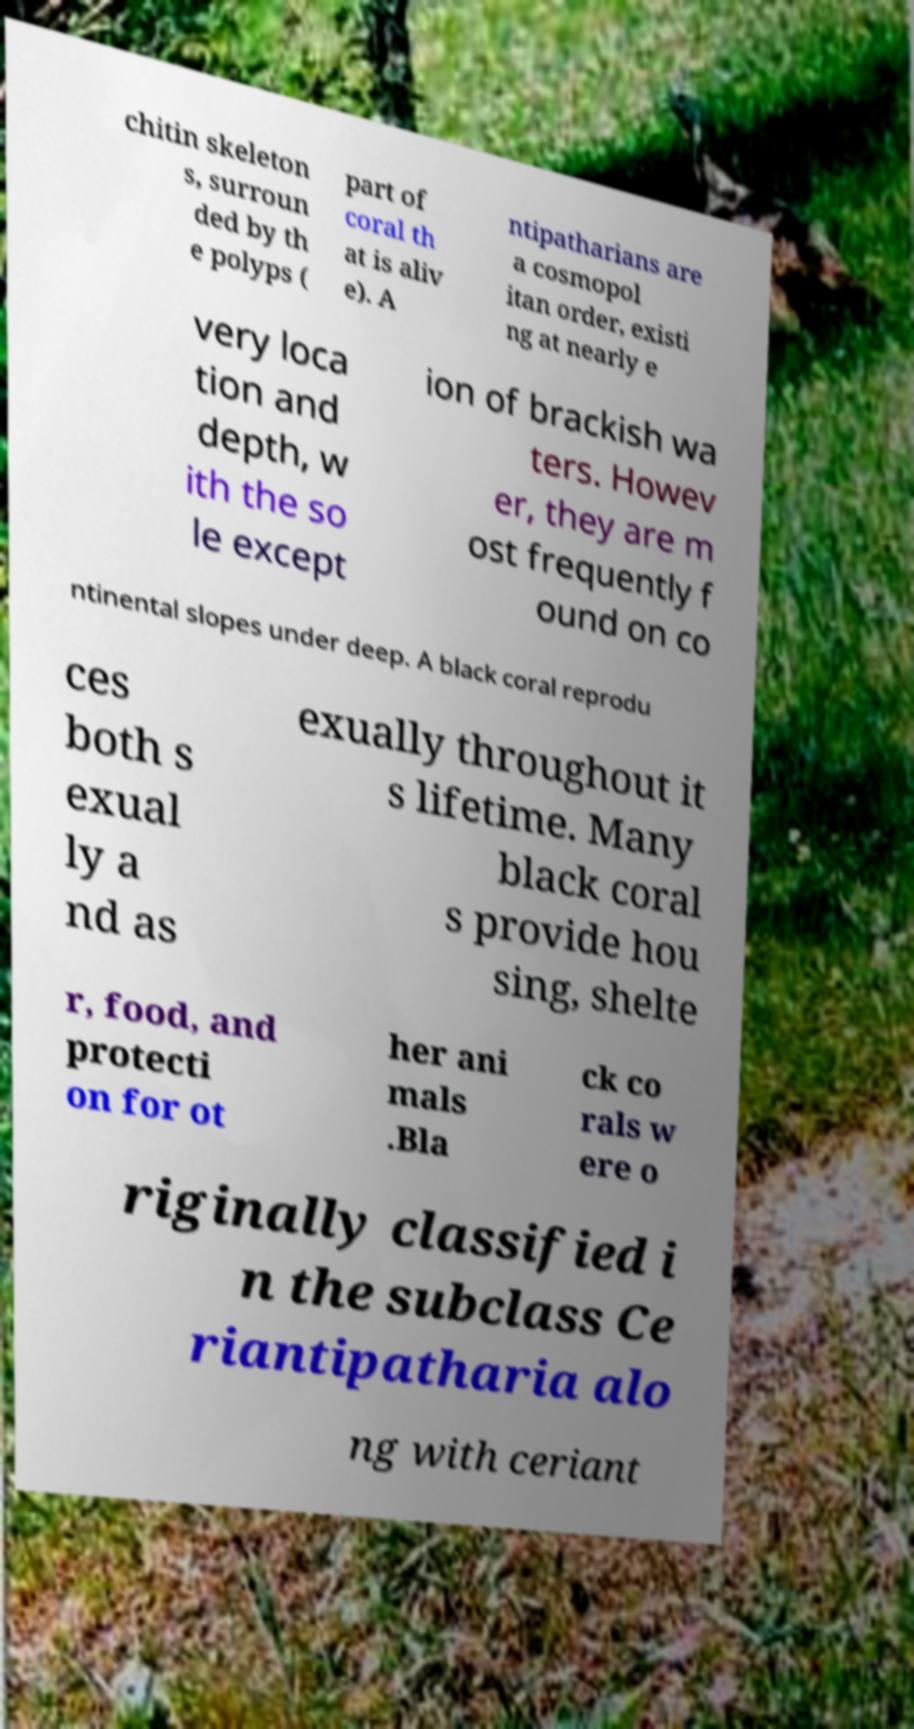Can you read and provide the text displayed in the image?This photo seems to have some interesting text. Can you extract and type it out for me? chitin skeleton s, surroun ded by th e polyps ( part of coral th at is aliv e). A ntipatharians are a cosmopol itan order, existi ng at nearly e very loca tion and depth, w ith the so le except ion of brackish wa ters. Howev er, they are m ost frequently f ound on co ntinental slopes under deep. A black coral reprodu ces both s exual ly a nd as exually throughout it s lifetime. Many black coral s provide hou sing, shelte r, food, and protecti on for ot her ani mals .Bla ck co rals w ere o riginally classified i n the subclass Ce riantipatharia alo ng with ceriant 